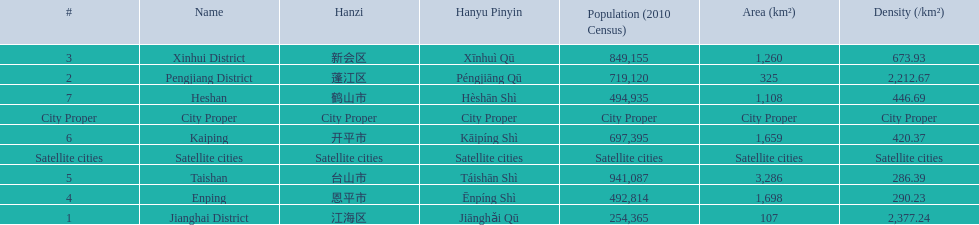Would you mind parsing the complete table? {'header': ['#', 'Name', 'Hanzi', 'Hanyu Pinyin', 'Population (2010 Census)', 'Area (km²)', 'Density (/km²)'], 'rows': [['3', 'Xinhui District', '新会区', 'Xīnhuì Qū', '849,155', '1,260', '673.93'], ['2', 'Pengjiang District', '蓬江区', 'Péngjiāng Qū', '719,120', '325', '2,212.67'], ['7', 'Heshan', '鹤山市', 'Hèshān Shì', '494,935', '1,108', '446.69'], ['City Proper', 'City Proper', 'City Proper', 'City Proper', 'City Proper', 'City Proper', 'City Proper'], ['6', 'Kaiping', '开平市', 'Kāipíng Shì', '697,395', '1,659', '420.37'], ['Satellite cities', 'Satellite cities', 'Satellite cities', 'Satellite cities', 'Satellite cities', 'Satellite cities', 'Satellite cities'], ['5', 'Taishan', '台山市', 'Táishān Shì', '941,087', '3,286', '286.39'], ['4', 'Enping', '恩平市', 'Ēnpíng Shì', '492,814', '1,698', '290.23'], ['1', 'Jianghai District', '江海区', 'Jiānghǎi Qū', '254,365', '107', '2,377.24']]} What is the difference in population between enping and heshan? 2121. 